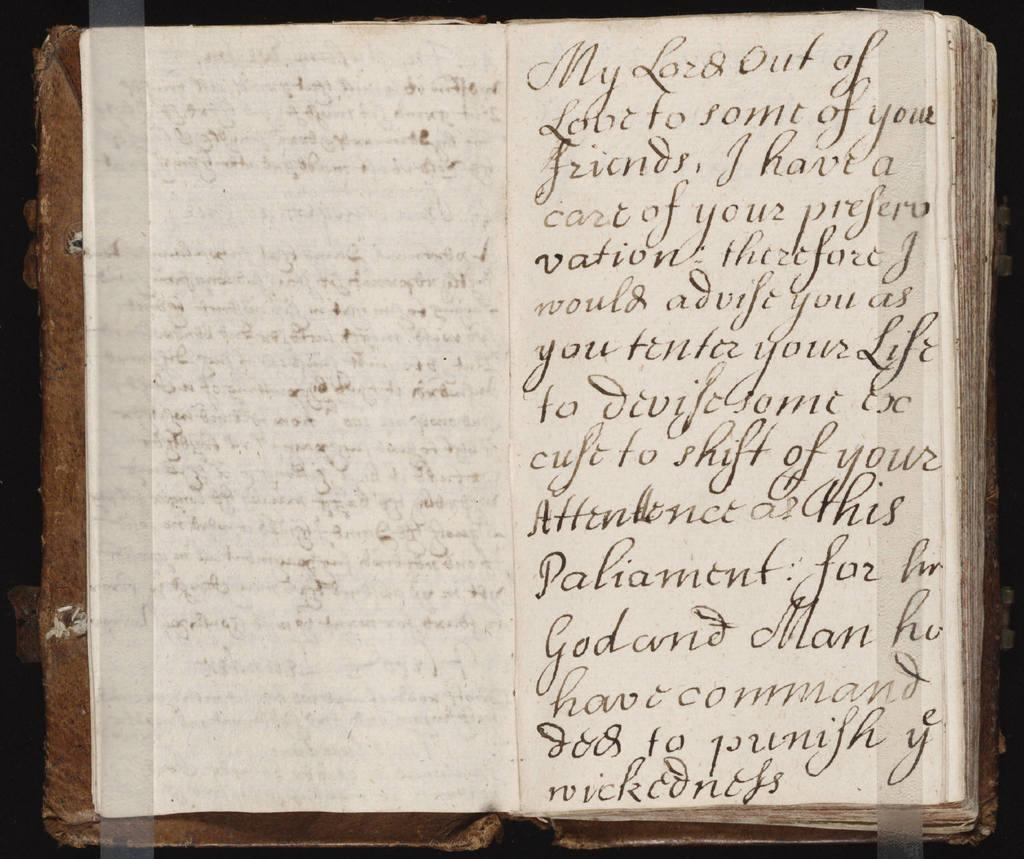<image>
Render a clear and concise summary of the photo. Old book written in old english that has meaning full points about God. 